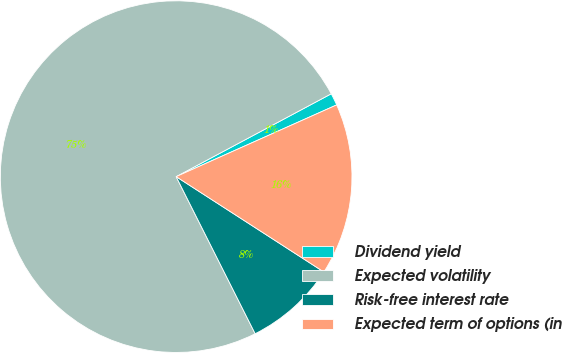Convert chart to OTSL. <chart><loc_0><loc_0><loc_500><loc_500><pie_chart><fcel>Dividend yield<fcel>Expected volatility<fcel>Risk-free interest rate<fcel>Expected term of options (in<nl><fcel>1.12%<fcel>74.61%<fcel>8.46%<fcel>15.81%<nl></chart> 